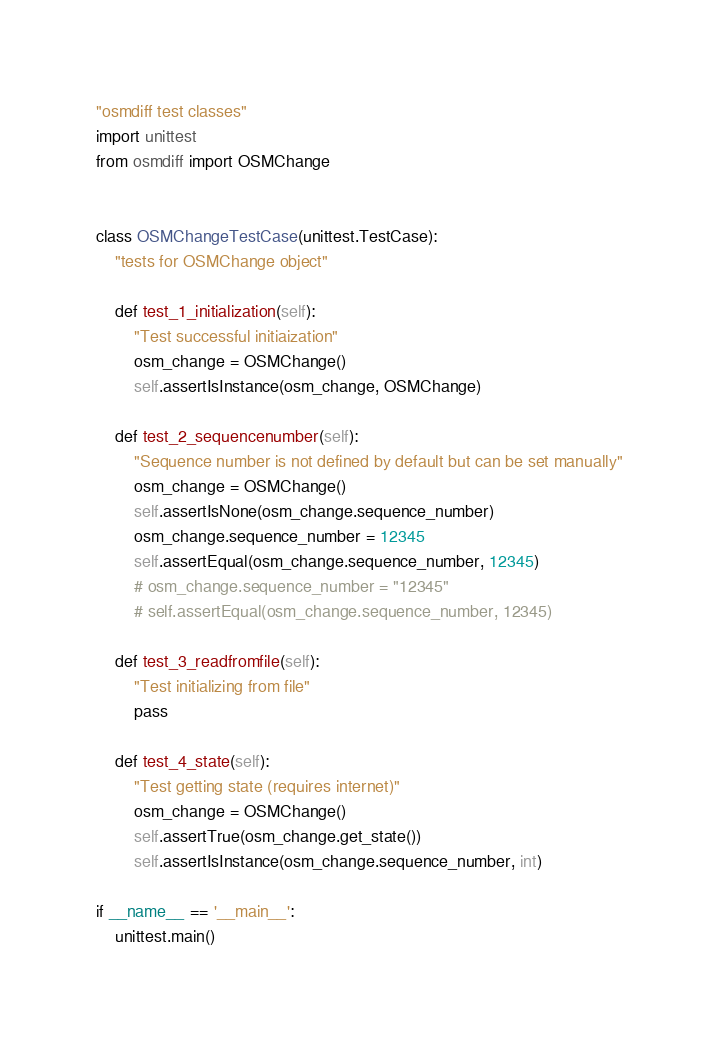<code> <loc_0><loc_0><loc_500><loc_500><_Python_>"osmdiff test classes"
import unittest
from osmdiff import OSMChange


class OSMChangeTestCase(unittest.TestCase):
    "tests for OSMChange object"

    def test_1_initialization(self):
        "Test successful initiaization"
        osm_change = OSMChange()
        self.assertIsInstance(osm_change, OSMChange)

    def test_2_sequencenumber(self):
        "Sequence number is not defined by default but can be set manually"
        osm_change = OSMChange()
        self.assertIsNone(osm_change.sequence_number)
        osm_change.sequence_number = 12345
        self.assertEqual(osm_change.sequence_number, 12345)
        # osm_change.sequence_number = "12345"
        # self.assertEqual(osm_change.sequence_number, 12345)

    def test_3_readfromfile(self):
        "Test initializing from file"
        pass

    def test_4_state(self):
        "Test getting state (requires internet)"
        osm_change = OSMChange()
        self.assertTrue(osm_change.get_state())
        self.assertIsInstance(osm_change.sequence_number, int)

if __name__ == '__main__':
    unittest.main()
</code> 